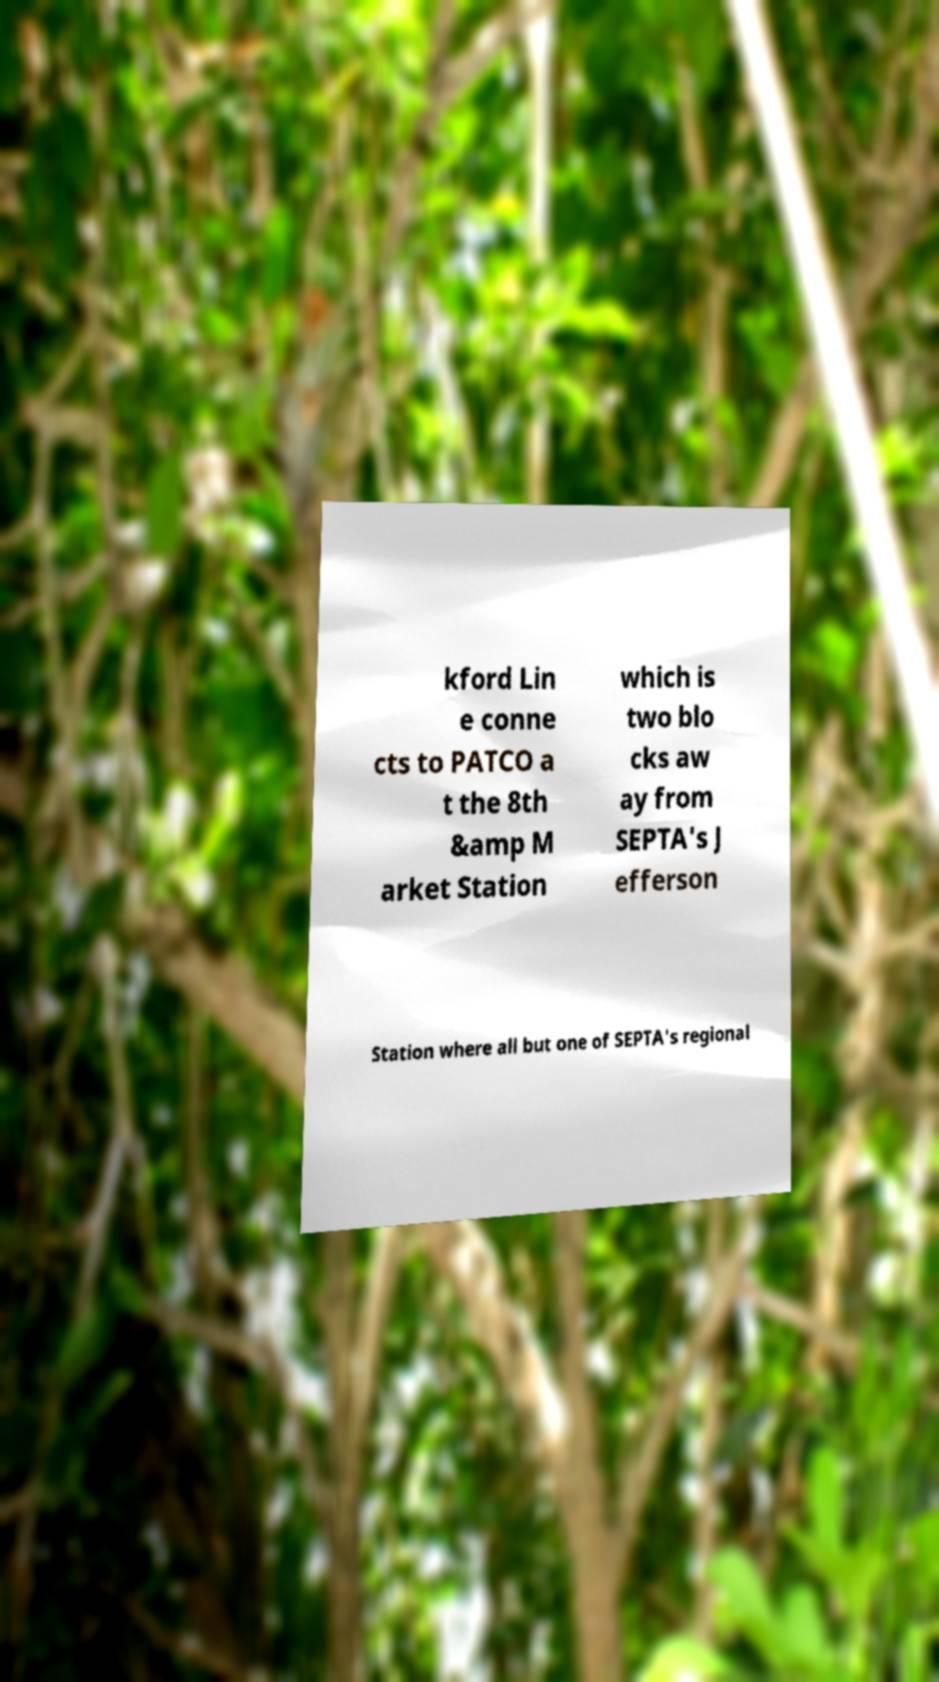For documentation purposes, I need the text within this image transcribed. Could you provide that? kford Lin e conne cts to PATCO a t the 8th &amp M arket Station which is two blo cks aw ay from SEPTA's J efferson Station where all but one of SEPTA's regional 